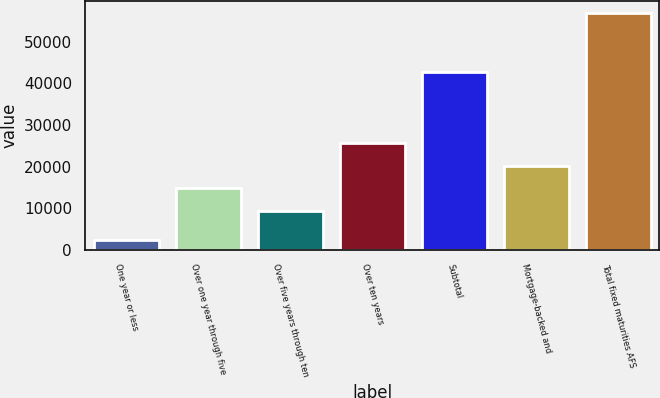<chart> <loc_0><loc_0><loc_500><loc_500><bar_chart><fcel>One year or less<fcel>Over one year through five<fcel>Over five years through ten<fcel>Over ten years<fcel>Subtotal<fcel>Mortgage-backed and<fcel>Total fixed maturities AFS<nl><fcel>2373<fcel>14781.2<fcel>9322<fcel>25699.6<fcel>42802<fcel>20240.4<fcel>56965<nl></chart> 